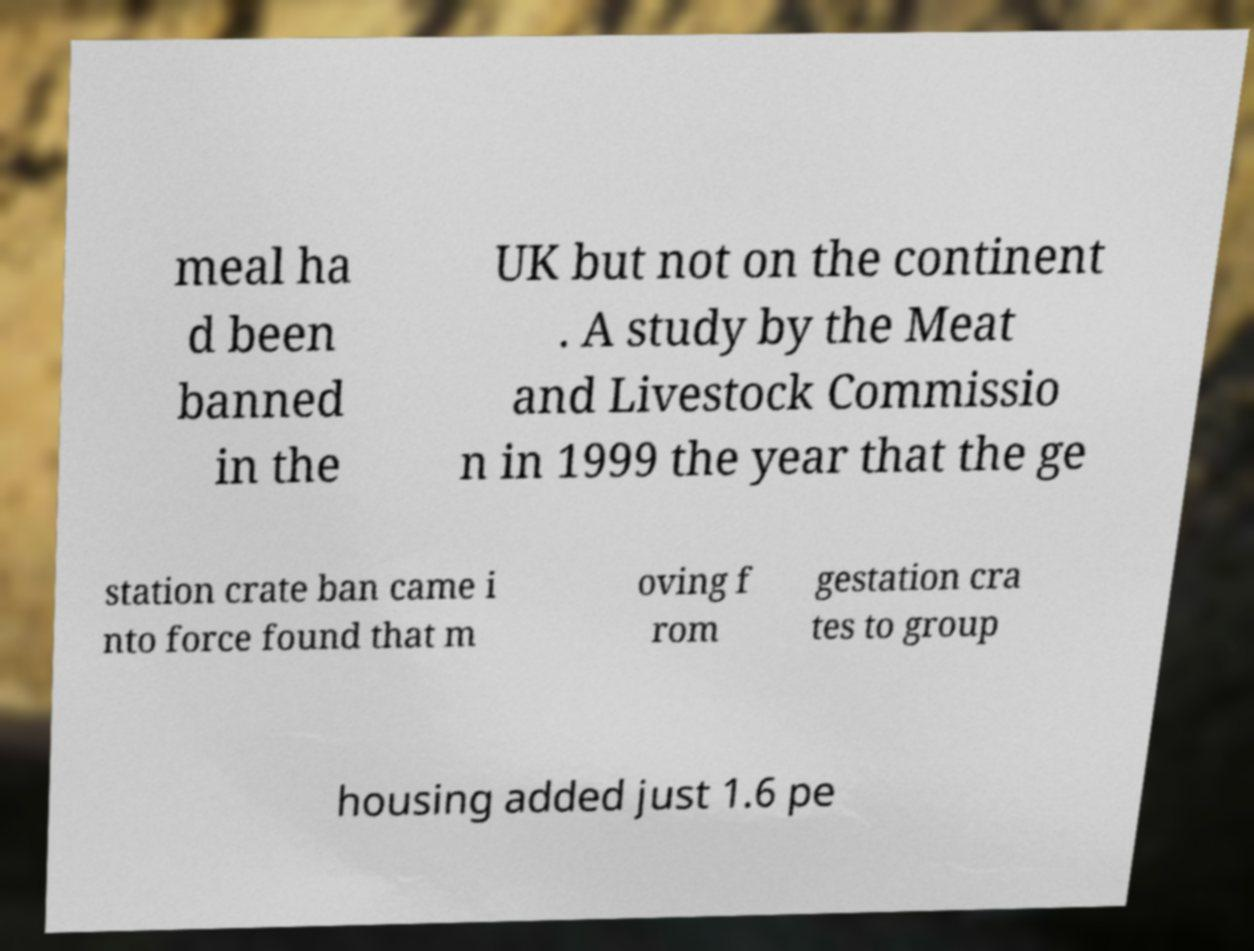What messages or text are displayed in this image? I need them in a readable, typed format. meal ha d been banned in the UK but not on the continent . A study by the Meat and Livestock Commissio n in 1999 the year that the ge station crate ban came i nto force found that m oving f rom gestation cra tes to group housing added just 1.6 pe 